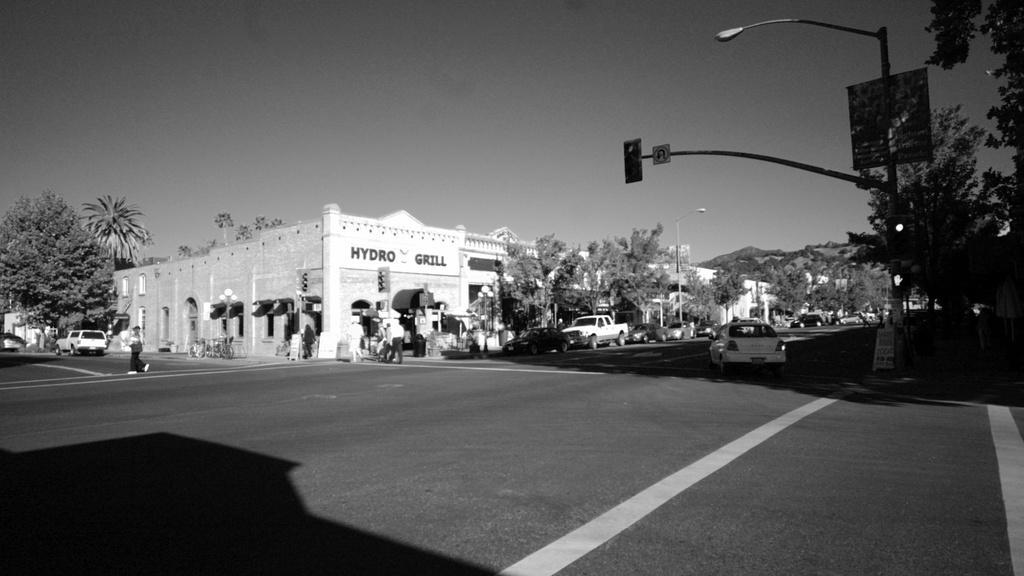Can you describe this image briefly? In this picture I can see there is a four way junction and there is a person walking on the road and there are few vehicles moving here and they are parked on to left here. There are trees and there is a building and the sky is clear. 